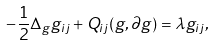<formula> <loc_0><loc_0><loc_500><loc_500>- { \frac { 1 } { 2 } } \Delta _ { g } g _ { i j } + Q _ { i j } ( g , \partial g ) = \lambda g _ { i j } ,</formula> 